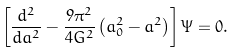Convert formula to latex. <formula><loc_0><loc_0><loc_500><loc_500>\left [ \frac { d ^ { 2 } } { d a ^ { 2 } } - \frac { 9 \pi ^ { 2 } } { 4 G ^ { 2 } } \left ( a _ { 0 } ^ { 2 } - a ^ { 2 } \right ) \right ] \Psi = 0 .</formula> 